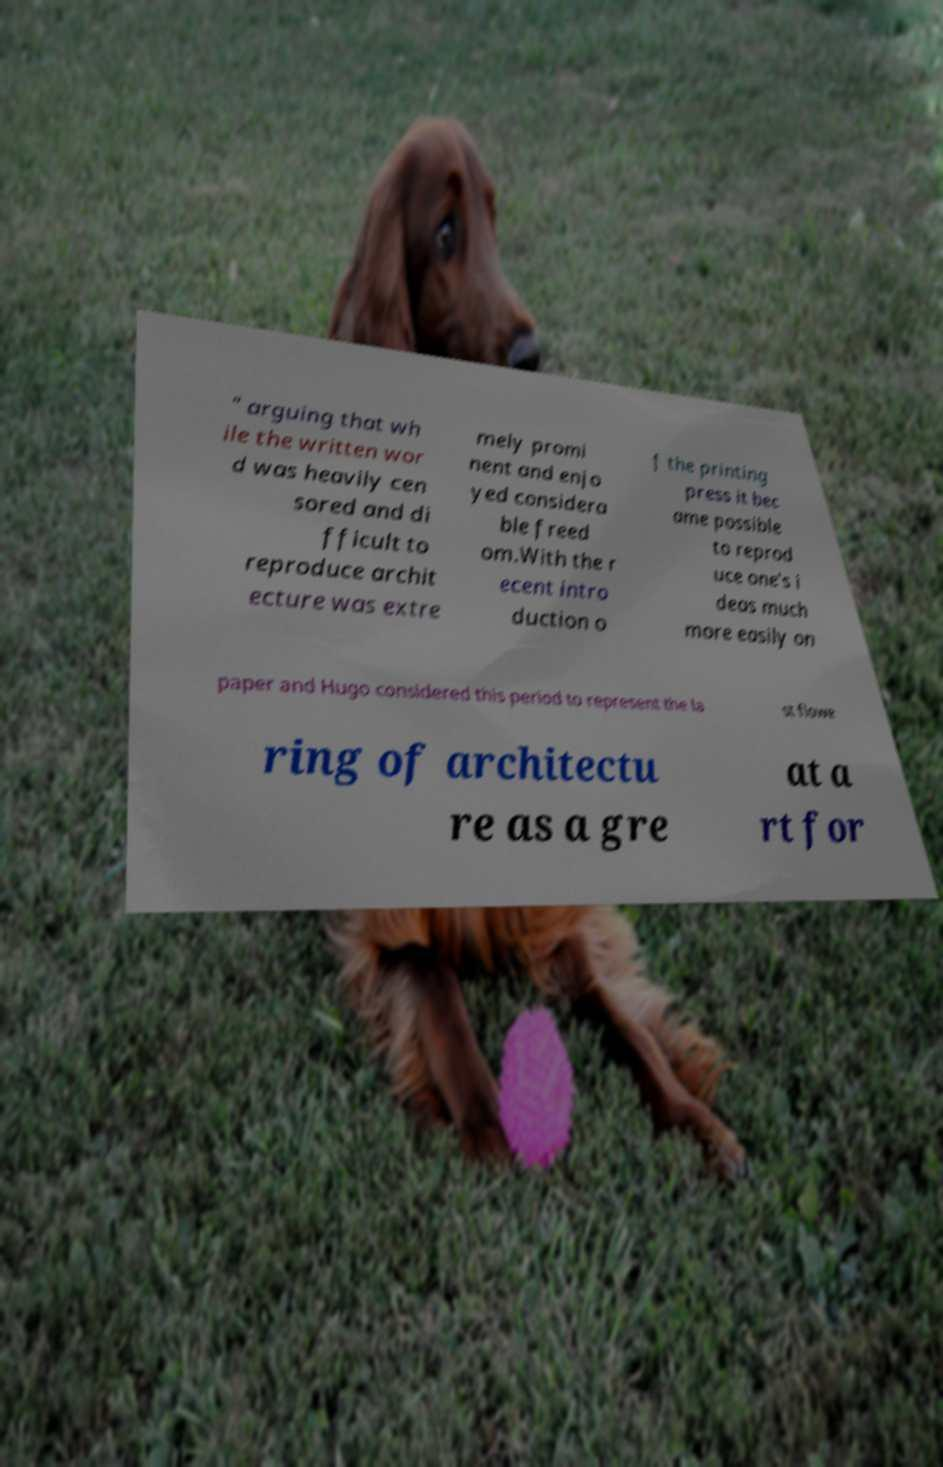There's text embedded in this image that I need extracted. Can you transcribe it verbatim? " arguing that wh ile the written wor d was heavily cen sored and di fficult to reproduce archit ecture was extre mely promi nent and enjo yed considera ble freed om.With the r ecent intro duction o f the printing press it bec ame possible to reprod uce one's i deas much more easily on paper and Hugo considered this period to represent the la st flowe ring of architectu re as a gre at a rt for 